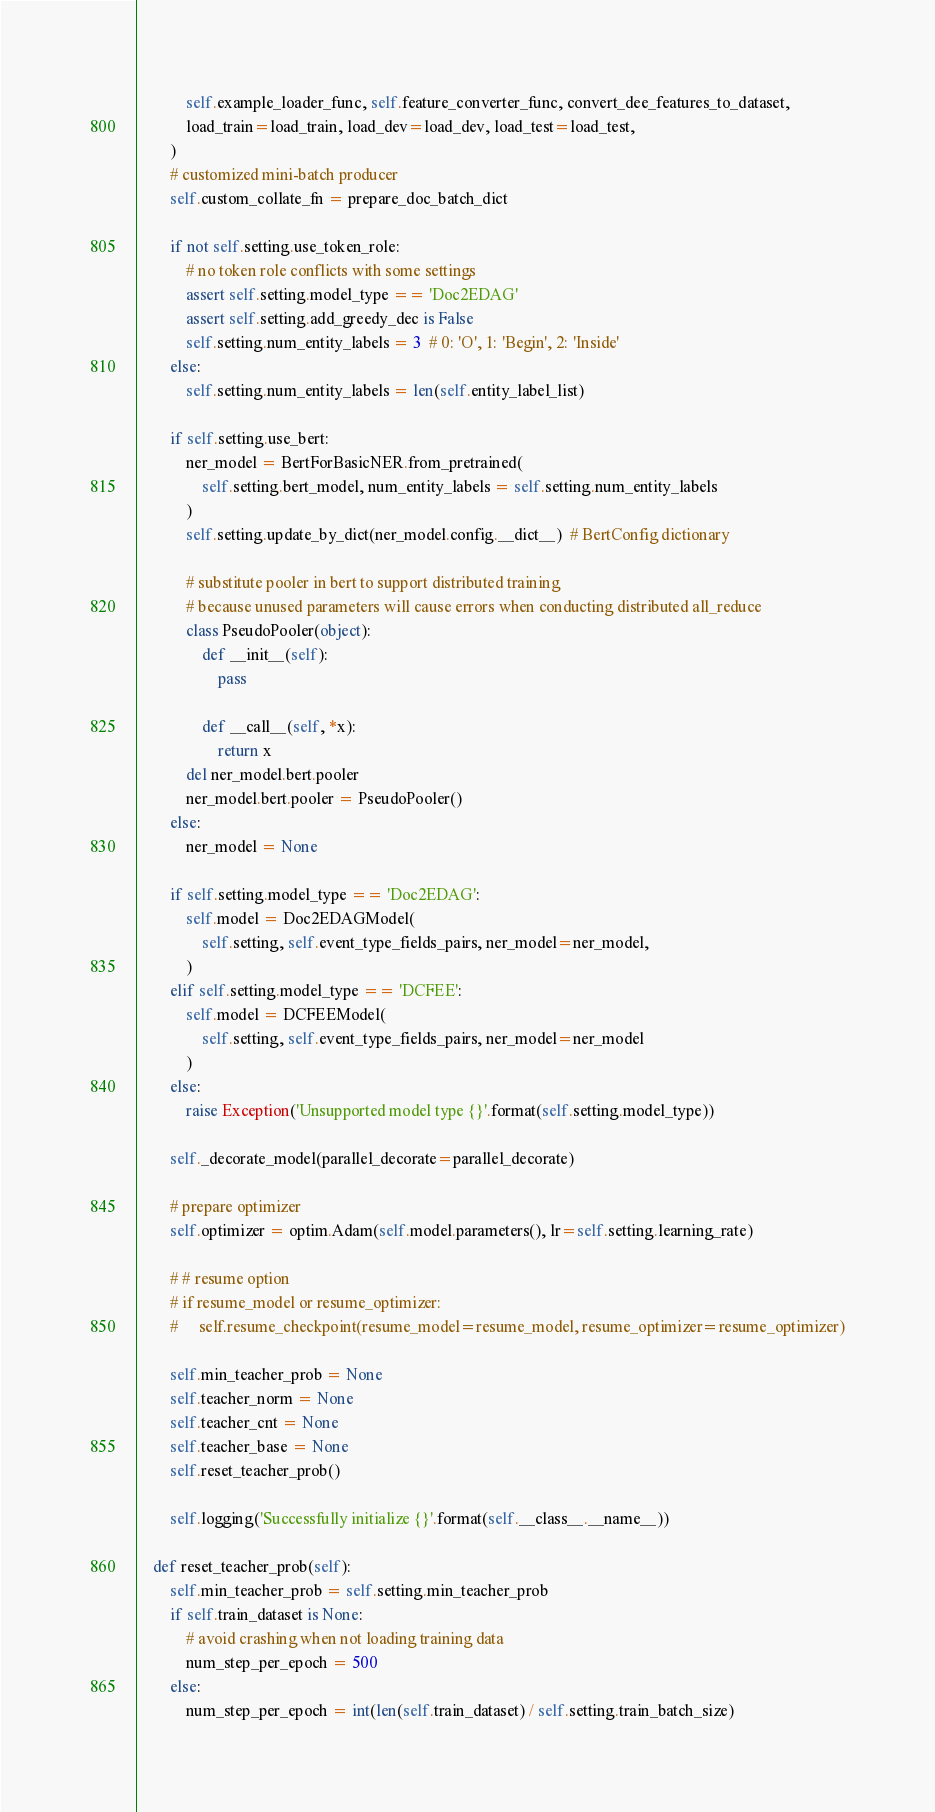Convert code to text. <code><loc_0><loc_0><loc_500><loc_500><_Python_>            self.example_loader_func, self.feature_converter_func, convert_dee_features_to_dataset,
            load_train=load_train, load_dev=load_dev, load_test=load_test,
        )
        # customized mini-batch producer
        self.custom_collate_fn = prepare_doc_batch_dict

        if not self.setting.use_token_role:
            # no token role conflicts with some settings
            assert self.setting.model_type == 'Doc2EDAG'
            assert self.setting.add_greedy_dec is False
            self.setting.num_entity_labels = 3  # 0: 'O', 1: 'Begin', 2: 'Inside'
        else:
            self.setting.num_entity_labels = len(self.entity_label_list)

        if self.setting.use_bert:
            ner_model = BertForBasicNER.from_pretrained(
                self.setting.bert_model, num_entity_labels = self.setting.num_entity_labels
            )
            self.setting.update_by_dict(ner_model.config.__dict__)  # BertConfig dictionary

            # substitute pooler in bert to support distributed training
            # because unused parameters will cause errors when conducting distributed all_reduce
            class PseudoPooler(object):
                def __init__(self):
                    pass

                def __call__(self, *x):
                    return x
            del ner_model.bert.pooler
            ner_model.bert.pooler = PseudoPooler()
        else:
            ner_model = None

        if self.setting.model_type == 'Doc2EDAG':
            self.model = Doc2EDAGModel(
                self.setting, self.event_type_fields_pairs, ner_model=ner_model,
            )
        elif self.setting.model_type == 'DCFEE':
            self.model = DCFEEModel(
                self.setting, self.event_type_fields_pairs, ner_model=ner_model
            )
        else:
            raise Exception('Unsupported model type {}'.format(self.setting.model_type))

        self._decorate_model(parallel_decorate=parallel_decorate)

        # prepare optimizer
        self.optimizer = optim.Adam(self.model.parameters(), lr=self.setting.learning_rate)

        # # resume option
        # if resume_model or resume_optimizer:
        #     self.resume_checkpoint(resume_model=resume_model, resume_optimizer=resume_optimizer)

        self.min_teacher_prob = None
        self.teacher_norm = None
        self.teacher_cnt = None
        self.teacher_base = None
        self.reset_teacher_prob()

        self.logging('Successfully initialize {}'.format(self.__class__.__name__))

    def reset_teacher_prob(self):
        self.min_teacher_prob = self.setting.min_teacher_prob
        if self.train_dataset is None:
            # avoid crashing when not loading training data
            num_step_per_epoch = 500
        else:
            num_step_per_epoch = int(len(self.train_dataset) / self.setting.train_batch_size)</code> 